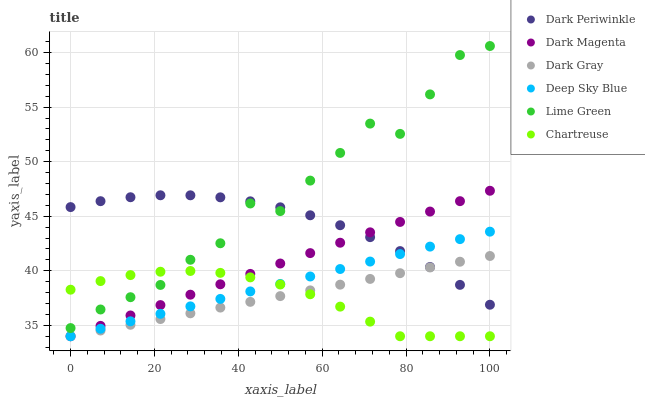Does Chartreuse have the minimum area under the curve?
Answer yes or no. Yes. Does Lime Green have the maximum area under the curve?
Answer yes or no. Yes. Does Dark Gray have the minimum area under the curve?
Answer yes or no. No. Does Dark Gray have the maximum area under the curve?
Answer yes or no. No. Is Dark Magenta the smoothest?
Answer yes or no. Yes. Is Lime Green the roughest?
Answer yes or no. Yes. Is Dark Gray the smoothest?
Answer yes or no. No. Is Dark Gray the roughest?
Answer yes or no. No. Does Dark Magenta have the lowest value?
Answer yes or no. Yes. Does Lime Green have the lowest value?
Answer yes or no. No. Does Lime Green have the highest value?
Answer yes or no. Yes. Does Dark Gray have the highest value?
Answer yes or no. No. Is Dark Gray less than Lime Green?
Answer yes or no. Yes. Is Lime Green greater than Dark Gray?
Answer yes or no. Yes. Does Chartreuse intersect Lime Green?
Answer yes or no. Yes. Is Chartreuse less than Lime Green?
Answer yes or no. No. Is Chartreuse greater than Lime Green?
Answer yes or no. No. Does Dark Gray intersect Lime Green?
Answer yes or no. No. 